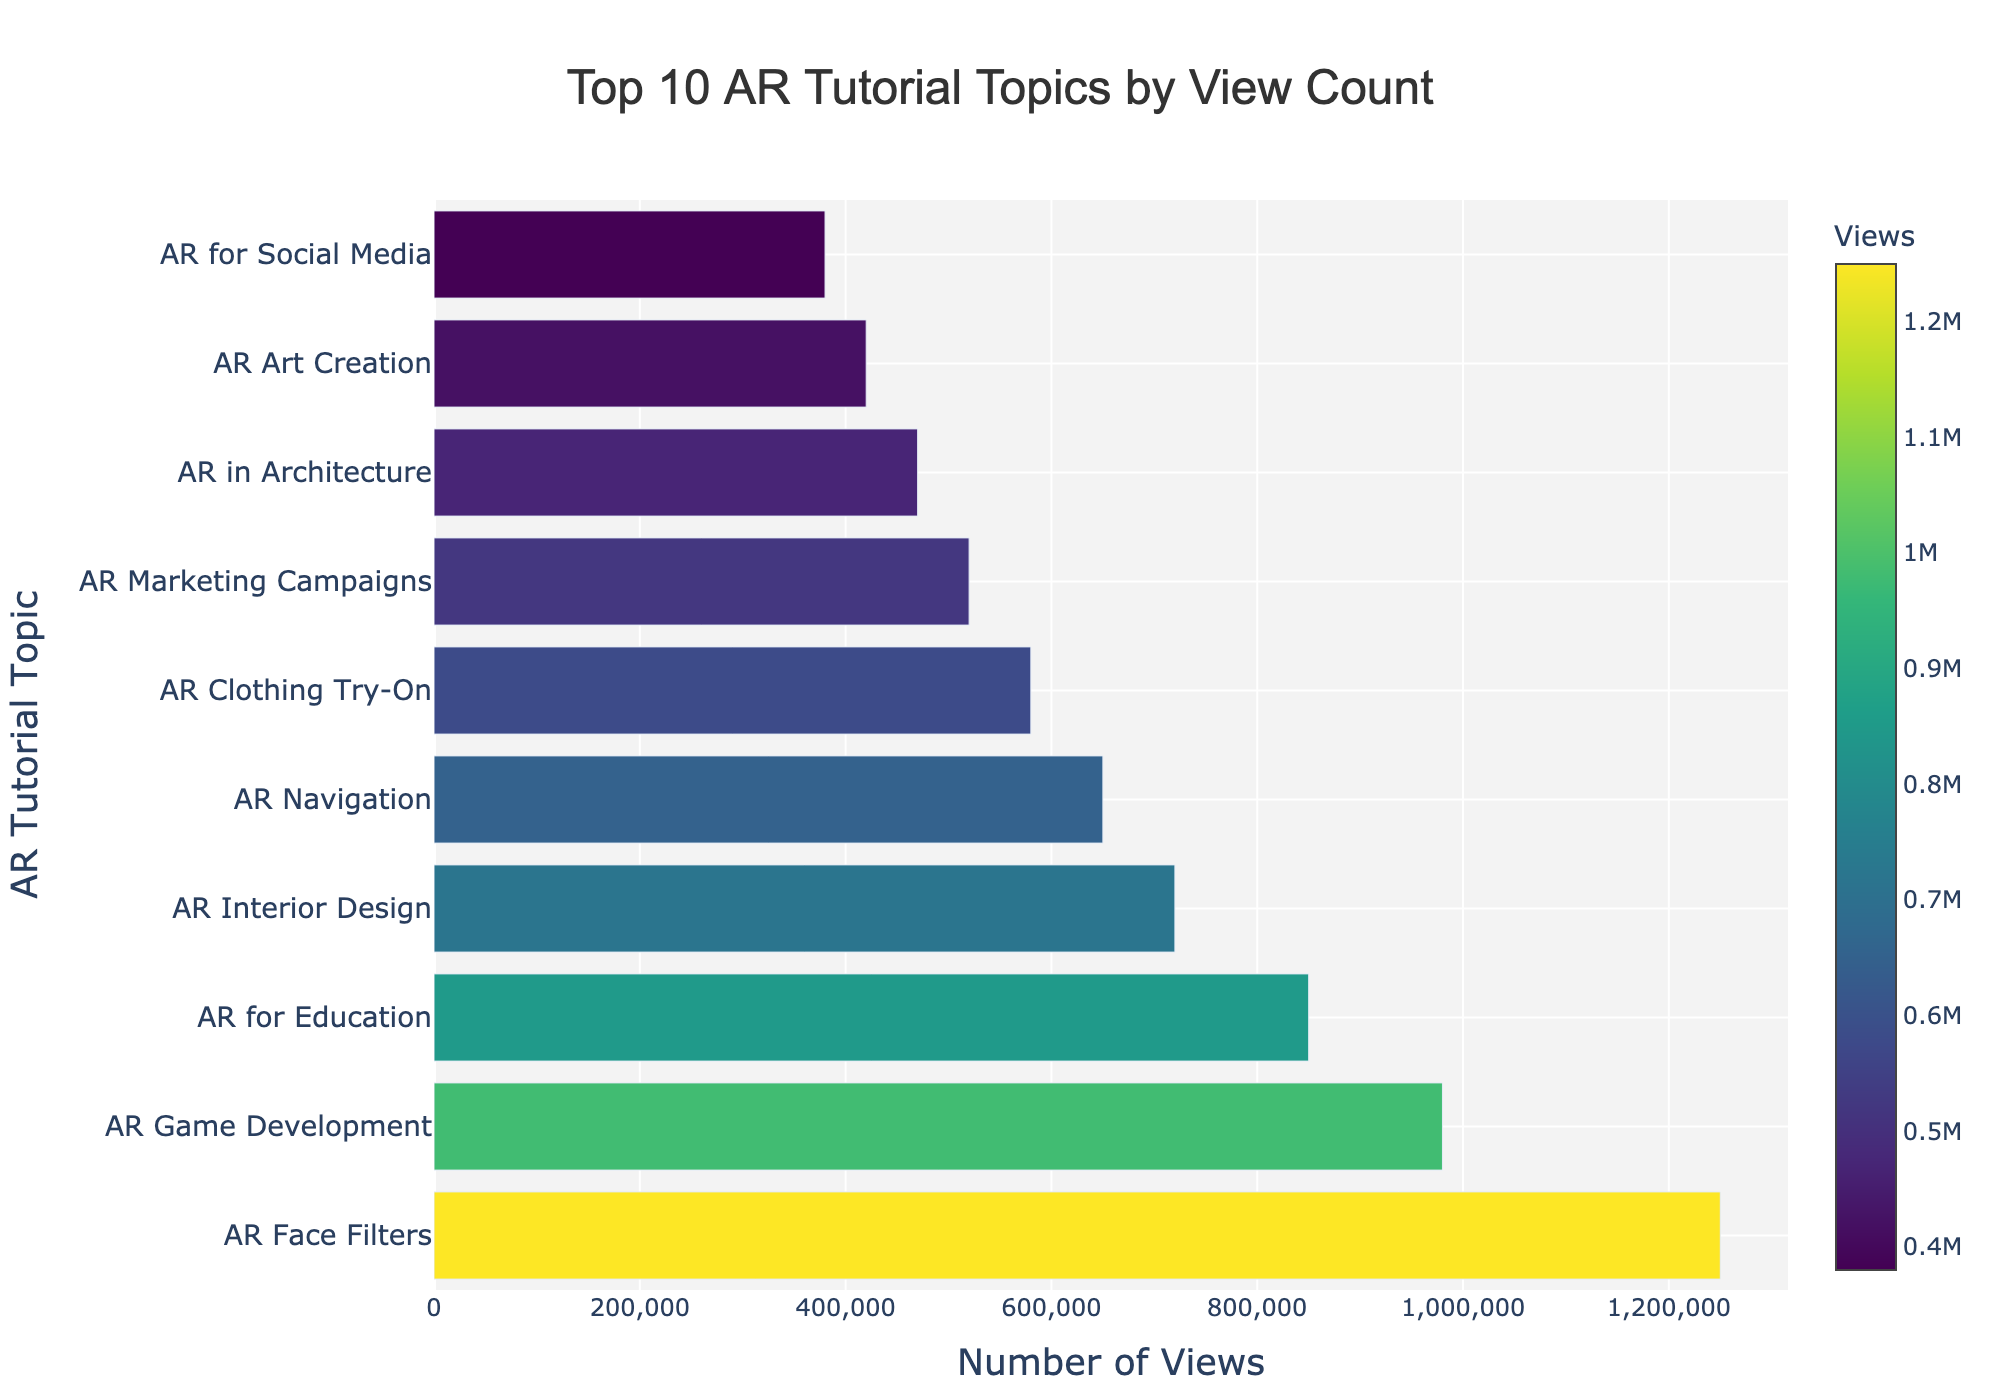What's the most viewed AR tutorial topic? The most viewed AR tutorial topic is the one with the highest bar length in the chart. The longest bar represents "AR Face Filters" with 1,250,000 views.
Answer: AR Face Filters Which AR tutorial topic has the least number of views among the top 10? The AR tutorial topic with the least number of views among the top 10 is the one with the shortest bar length in the chart. The shortest bar represents "AR for Social Media" with 380,000 views.
Answer: AR for Social Media What's the combined view count of the top 3 AR tutorial topics? To find the combined view count, sum the views of the top 3 topics. "AR Face Filters" (1,250,000), "AR Game Development" (980,000), and "AR for Education" (850,000). Adding these together, 1,250,000 + 980,000 + 850,000 = 3,080,000.
Answer: 3,080,000 Which has more views: "AR Interior Design" or "AR Marketing Campaigns"? Compare the length of the bars for "AR Interior Design" and "AR Marketing Campaigns". "AR Interior Design" has 720,000 views, whereas "AR Marketing Campaigns" has 520,000 views. Therefore, "AR Interior Design" has more views.
Answer: AR Interior Design What’s the difference in view count between "AR Navigation" and "AR Game Development"? Subtract the view count of "AR Navigation" from "AR Game Development". "AR Game Development" has 980,000 views and "AR Navigation" has 650,000 views. The difference is 980,000 - 650,000 = 330,000.
Answer: 330,000 Which AR tutorial topic has the most similar view count to "AR Art Creation"? Identify the bar lengths close to 420,000 views which represents "AR Art Creation". Each topic’s views are: "AR in Architecture" (470,000), "AR for Social Media" (380,000), and "AR Marketing Campaigns" (520,000). "AR for Social Media" with 380,000 is the closest.
Answer: AR for Social Media How many total views do the bottom 5 of the top 10 AR tutorial topics have? Sum the views of the 6th to 10th topics. "AR Marketing Campaigns" (520,000), "AR in Architecture" (470,000), "AR Art Creation" (420,000), "AR for Social Media" (380,000), "AR in Retail" (350,000). Adding these together, 520,000 + 470,000 + 420,000 + 380,000 + 350,000 = 2,140,000.
Answer: 2,140,000 Which AR tutorial topic is ranked fifth by view count? The fifth longest bar represents the AR tutorial topic ranked fifth by views. The topic is "AR Navigation" with 650,000 views.
Answer: AR Navigation 